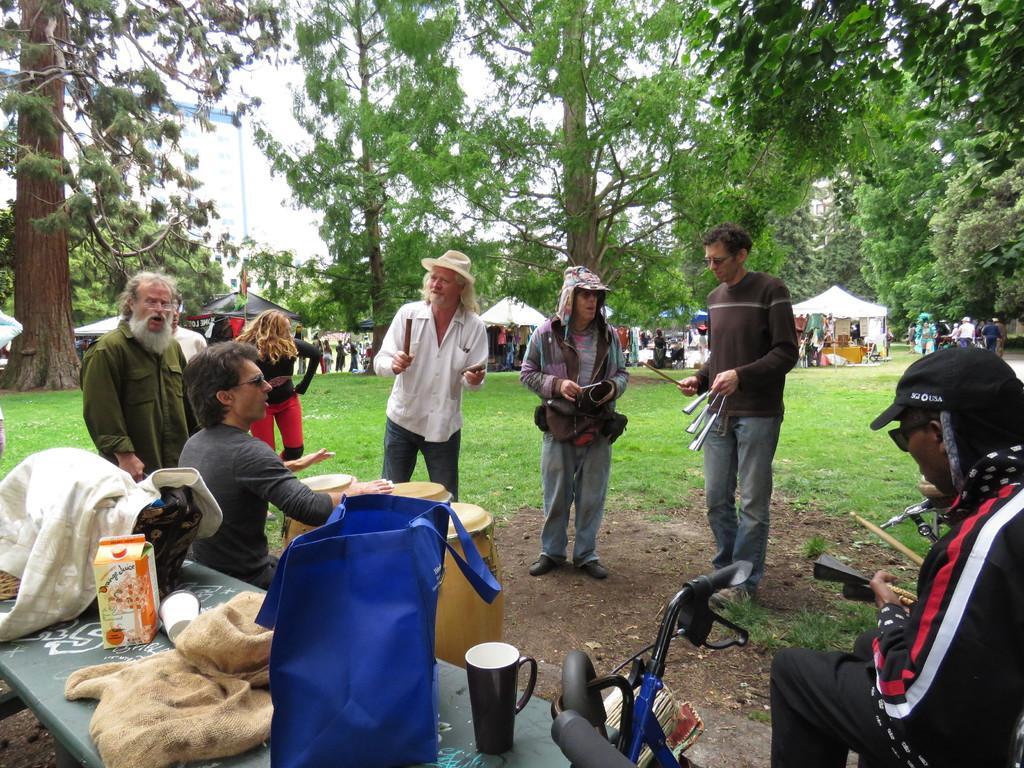Can you describe this image briefly? This image consists of many people. In the front, we can see a man playing drums. On the right, the three men are holding musical instruments. On the left, there is a table on which there are cups and bags. At the bottom, there is a cycle. In the background, there are many trees and tents. And we can see many people near the tents. At the bottom, there is green grass on the ground. At the top, there is sky. 